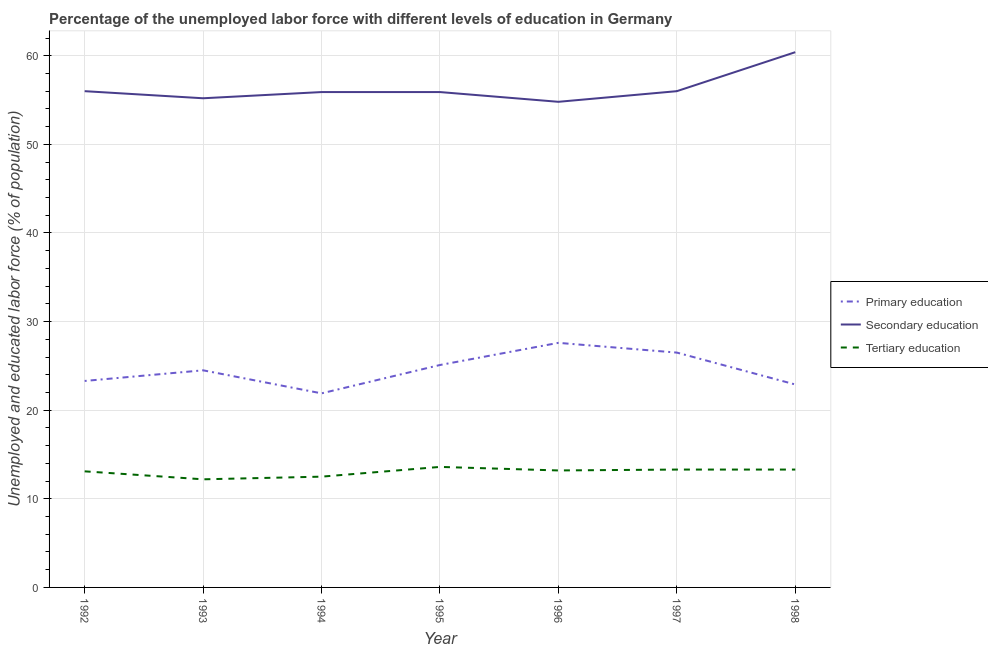How many different coloured lines are there?
Make the answer very short. 3. Does the line corresponding to percentage of labor force who received primary education intersect with the line corresponding to percentage of labor force who received tertiary education?
Provide a succinct answer. No. What is the percentage of labor force who received tertiary education in 1996?
Offer a very short reply. 13.2. Across all years, what is the maximum percentage of labor force who received primary education?
Give a very brief answer. 27.6. Across all years, what is the minimum percentage of labor force who received primary education?
Offer a terse response. 21.9. In which year was the percentage of labor force who received secondary education maximum?
Your response must be concise. 1998. What is the total percentage of labor force who received primary education in the graph?
Ensure brevity in your answer.  171.8. What is the difference between the percentage of labor force who received secondary education in 1994 and that in 1996?
Your response must be concise. 1.1. What is the difference between the percentage of labor force who received tertiary education in 1994 and the percentage of labor force who received secondary education in 1996?
Provide a short and direct response. -42.3. What is the average percentage of labor force who received secondary education per year?
Offer a very short reply. 56.31. In the year 1993, what is the difference between the percentage of labor force who received primary education and percentage of labor force who received tertiary education?
Offer a very short reply. 12.3. In how many years, is the percentage of labor force who received primary education greater than 12 %?
Make the answer very short. 7. What is the ratio of the percentage of labor force who received secondary education in 1994 to that in 1998?
Your answer should be compact. 0.93. Is the percentage of labor force who received primary education in 1994 less than that in 1996?
Your answer should be very brief. Yes. What is the difference between the highest and the second highest percentage of labor force who received primary education?
Give a very brief answer. 1.1. What is the difference between the highest and the lowest percentage of labor force who received tertiary education?
Provide a short and direct response. 1.4. In how many years, is the percentage of labor force who received secondary education greater than the average percentage of labor force who received secondary education taken over all years?
Your answer should be very brief. 1. Is the sum of the percentage of labor force who received secondary education in 1995 and 1996 greater than the maximum percentage of labor force who received tertiary education across all years?
Offer a very short reply. Yes. Is it the case that in every year, the sum of the percentage of labor force who received primary education and percentage of labor force who received secondary education is greater than the percentage of labor force who received tertiary education?
Your answer should be very brief. Yes. Does the percentage of labor force who received secondary education monotonically increase over the years?
Make the answer very short. No. Is the percentage of labor force who received tertiary education strictly less than the percentage of labor force who received primary education over the years?
Ensure brevity in your answer.  Yes. How many lines are there?
Provide a short and direct response. 3. How many years are there in the graph?
Ensure brevity in your answer.  7. What is the difference between two consecutive major ticks on the Y-axis?
Make the answer very short. 10. Are the values on the major ticks of Y-axis written in scientific E-notation?
Give a very brief answer. No. Does the graph contain any zero values?
Make the answer very short. No. Does the graph contain grids?
Ensure brevity in your answer.  Yes. Where does the legend appear in the graph?
Your answer should be compact. Center right. What is the title of the graph?
Provide a succinct answer. Percentage of the unemployed labor force with different levels of education in Germany. Does "Natural gas sources" appear as one of the legend labels in the graph?
Give a very brief answer. No. What is the label or title of the Y-axis?
Your response must be concise. Unemployed and educated labor force (% of population). What is the Unemployed and educated labor force (% of population) in Primary education in 1992?
Provide a succinct answer. 23.3. What is the Unemployed and educated labor force (% of population) of Tertiary education in 1992?
Keep it short and to the point. 13.1. What is the Unemployed and educated labor force (% of population) of Secondary education in 1993?
Offer a terse response. 55.2. What is the Unemployed and educated labor force (% of population) of Tertiary education in 1993?
Your response must be concise. 12.2. What is the Unemployed and educated labor force (% of population) of Primary education in 1994?
Offer a terse response. 21.9. What is the Unemployed and educated labor force (% of population) in Secondary education in 1994?
Provide a short and direct response. 55.9. What is the Unemployed and educated labor force (% of population) of Primary education in 1995?
Make the answer very short. 25.1. What is the Unemployed and educated labor force (% of population) in Secondary education in 1995?
Give a very brief answer. 55.9. What is the Unemployed and educated labor force (% of population) in Tertiary education in 1995?
Your answer should be compact. 13.6. What is the Unemployed and educated labor force (% of population) in Primary education in 1996?
Ensure brevity in your answer.  27.6. What is the Unemployed and educated labor force (% of population) in Secondary education in 1996?
Keep it short and to the point. 54.8. What is the Unemployed and educated labor force (% of population) of Tertiary education in 1996?
Offer a very short reply. 13.2. What is the Unemployed and educated labor force (% of population) of Secondary education in 1997?
Give a very brief answer. 56. What is the Unemployed and educated labor force (% of population) in Tertiary education in 1997?
Provide a short and direct response. 13.3. What is the Unemployed and educated labor force (% of population) in Primary education in 1998?
Offer a very short reply. 22.9. What is the Unemployed and educated labor force (% of population) in Secondary education in 1998?
Keep it short and to the point. 60.4. What is the Unemployed and educated labor force (% of population) of Tertiary education in 1998?
Provide a succinct answer. 13.3. Across all years, what is the maximum Unemployed and educated labor force (% of population) of Primary education?
Keep it short and to the point. 27.6. Across all years, what is the maximum Unemployed and educated labor force (% of population) of Secondary education?
Keep it short and to the point. 60.4. Across all years, what is the maximum Unemployed and educated labor force (% of population) of Tertiary education?
Your response must be concise. 13.6. Across all years, what is the minimum Unemployed and educated labor force (% of population) of Primary education?
Keep it short and to the point. 21.9. Across all years, what is the minimum Unemployed and educated labor force (% of population) in Secondary education?
Provide a succinct answer. 54.8. Across all years, what is the minimum Unemployed and educated labor force (% of population) in Tertiary education?
Make the answer very short. 12.2. What is the total Unemployed and educated labor force (% of population) of Primary education in the graph?
Give a very brief answer. 171.8. What is the total Unemployed and educated labor force (% of population) in Secondary education in the graph?
Offer a terse response. 394.2. What is the total Unemployed and educated labor force (% of population) in Tertiary education in the graph?
Ensure brevity in your answer.  91.2. What is the difference between the Unemployed and educated labor force (% of population) of Primary education in 1992 and that in 1993?
Keep it short and to the point. -1.2. What is the difference between the Unemployed and educated labor force (% of population) in Tertiary education in 1992 and that in 1993?
Provide a short and direct response. 0.9. What is the difference between the Unemployed and educated labor force (% of population) in Primary education in 1992 and that in 1996?
Give a very brief answer. -4.3. What is the difference between the Unemployed and educated labor force (% of population) of Tertiary education in 1992 and that in 1996?
Provide a succinct answer. -0.1. What is the difference between the Unemployed and educated labor force (% of population) in Primary education in 1992 and that in 1998?
Provide a succinct answer. 0.4. What is the difference between the Unemployed and educated labor force (% of population) of Tertiary education in 1993 and that in 1994?
Your answer should be very brief. -0.3. What is the difference between the Unemployed and educated labor force (% of population) in Secondary education in 1993 and that in 1995?
Give a very brief answer. -0.7. What is the difference between the Unemployed and educated labor force (% of population) in Primary education in 1993 and that in 1996?
Make the answer very short. -3.1. What is the difference between the Unemployed and educated labor force (% of population) of Primary education in 1993 and that in 1997?
Your answer should be very brief. -2. What is the difference between the Unemployed and educated labor force (% of population) of Secondary education in 1993 and that in 1997?
Keep it short and to the point. -0.8. What is the difference between the Unemployed and educated labor force (% of population) in Primary education in 1993 and that in 1998?
Give a very brief answer. 1.6. What is the difference between the Unemployed and educated labor force (% of population) in Secondary education in 1993 and that in 1998?
Make the answer very short. -5.2. What is the difference between the Unemployed and educated labor force (% of population) in Tertiary education in 1994 and that in 1995?
Provide a short and direct response. -1.1. What is the difference between the Unemployed and educated labor force (% of population) of Primary education in 1994 and that in 1996?
Make the answer very short. -5.7. What is the difference between the Unemployed and educated labor force (% of population) in Secondary education in 1994 and that in 1996?
Your answer should be very brief. 1.1. What is the difference between the Unemployed and educated labor force (% of population) of Primary education in 1994 and that in 1997?
Keep it short and to the point. -4.6. What is the difference between the Unemployed and educated labor force (% of population) of Secondary education in 1994 and that in 1997?
Provide a short and direct response. -0.1. What is the difference between the Unemployed and educated labor force (% of population) of Primary education in 1994 and that in 1998?
Offer a very short reply. -1. What is the difference between the Unemployed and educated labor force (% of population) of Primary education in 1995 and that in 1996?
Offer a very short reply. -2.5. What is the difference between the Unemployed and educated labor force (% of population) in Primary education in 1995 and that in 1997?
Offer a very short reply. -1.4. What is the difference between the Unemployed and educated labor force (% of population) of Secondary education in 1995 and that in 1997?
Your response must be concise. -0.1. What is the difference between the Unemployed and educated labor force (% of population) of Primary education in 1995 and that in 1998?
Keep it short and to the point. 2.2. What is the difference between the Unemployed and educated labor force (% of population) of Secondary education in 1995 and that in 1998?
Provide a succinct answer. -4.5. What is the difference between the Unemployed and educated labor force (% of population) of Tertiary education in 1995 and that in 1998?
Keep it short and to the point. 0.3. What is the difference between the Unemployed and educated labor force (% of population) of Primary education in 1996 and that in 1997?
Your answer should be very brief. 1.1. What is the difference between the Unemployed and educated labor force (% of population) in Secondary education in 1996 and that in 1997?
Offer a terse response. -1.2. What is the difference between the Unemployed and educated labor force (% of population) of Tertiary education in 1996 and that in 1997?
Your answer should be very brief. -0.1. What is the difference between the Unemployed and educated labor force (% of population) of Primary education in 1996 and that in 1998?
Provide a short and direct response. 4.7. What is the difference between the Unemployed and educated labor force (% of population) of Primary education in 1997 and that in 1998?
Provide a succinct answer. 3.6. What is the difference between the Unemployed and educated labor force (% of population) of Tertiary education in 1997 and that in 1998?
Your answer should be compact. 0. What is the difference between the Unemployed and educated labor force (% of population) of Primary education in 1992 and the Unemployed and educated labor force (% of population) of Secondary education in 1993?
Your answer should be very brief. -31.9. What is the difference between the Unemployed and educated labor force (% of population) of Secondary education in 1992 and the Unemployed and educated labor force (% of population) of Tertiary education in 1993?
Ensure brevity in your answer.  43.8. What is the difference between the Unemployed and educated labor force (% of population) of Primary education in 1992 and the Unemployed and educated labor force (% of population) of Secondary education in 1994?
Provide a succinct answer. -32.6. What is the difference between the Unemployed and educated labor force (% of population) of Primary education in 1992 and the Unemployed and educated labor force (% of population) of Tertiary education in 1994?
Your response must be concise. 10.8. What is the difference between the Unemployed and educated labor force (% of population) of Secondary education in 1992 and the Unemployed and educated labor force (% of population) of Tertiary education in 1994?
Ensure brevity in your answer.  43.5. What is the difference between the Unemployed and educated labor force (% of population) of Primary education in 1992 and the Unemployed and educated labor force (% of population) of Secondary education in 1995?
Keep it short and to the point. -32.6. What is the difference between the Unemployed and educated labor force (% of population) of Primary education in 1992 and the Unemployed and educated labor force (% of population) of Tertiary education in 1995?
Offer a terse response. 9.7. What is the difference between the Unemployed and educated labor force (% of population) in Secondary education in 1992 and the Unemployed and educated labor force (% of population) in Tertiary education in 1995?
Your answer should be compact. 42.4. What is the difference between the Unemployed and educated labor force (% of population) in Primary education in 1992 and the Unemployed and educated labor force (% of population) in Secondary education in 1996?
Your answer should be compact. -31.5. What is the difference between the Unemployed and educated labor force (% of population) in Primary education in 1992 and the Unemployed and educated labor force (% of population) in Tertiary education in 1996?
Your response must be concise. 10.1. What is the difference between the Unemployed and educated labor force (% of population) of Secondary education in 1992 and the Unemployed and educated labor force (% of population) of Tertiary education in 1996?
Ensure brevity in your answer.  42.8. What is the difference between the Unemployed and educated labor force (% of population) of Primary education in 1992 and the Unemployed and educated labor force (% of population) of Secondary education in 1997?
Your response must be concise. -32.7. What is the difference between the Unemployed and educated labor force (% of population) in Secondary education in 1992 and the Unemployed and educated labor force (% of population) in Tertiary education in 1997?
Your answer should be compact. 42.7. What is the difference between the Unemployed and educated labor force (% of population) of Primary education in 1992 and the Unemployed and educated labor force (% of population) of Secondary education in 1998?
Give a very brief answer. -37.1. What is the difference between the Unemployed and educated labor force (% of population) in Primary education in 1992 and the Unemployed and educated labor force (% of population) in Tertiary education in 1998?
Give a very brief answer. 10. What is the difference between the Unemployed and educated labor force (% of population) of Secondary education in 1992 and the Unemployed and educated labor force (% of population) of Tertiary education in 1998?
Your answer should be very brief. 42.7. What is the difference between the Unemployed and educated labor force (% of population) of Primary education in 1993 and the Unemployed and educated labor force (% of population) of Secondary education in 1994?
Give a very brief answer. -31.4. What is the difference between the Unemployed and educated labor force (% of population) of Primary education in 1993 and the Unemployed and educated labor force (% of population) of Tertiary education in 1994?
Provide a succinct answer. 12. What is the difference between the Unemployed and educated labor force (% of population) in Secondary education in 1993 and the Unemployed and educated labor force (% of population) in Tertiary education in 1994?
Your answer should be compact. 42.7. What is the difference between the Unemployed and educated labor force (% of population) of Primary education in 1993 and the Unemployed and educated labor force (% of population) of Secondary education in 1995?
Ensure brevity in your answer.  -31.4. What is the difference between the Unemployed and educated labor force (% of population) of Secondary education in 1993 and the Unemployed and educated labor force (% of population) of Tertiary education in 1995?
Offer a very short reply. 41.6. What is the difference between the Unemployed and educated labor force (% of population) of Primary education in 1993 and the Unemployed and educated labor force (% of population) of Secondary education in 1996?
Your answer should be very brief. -30.3. What is the difference between the Unemployed and educated labor force (% of population) in Secondary education in 1993 and the Unemployed and educated labor force (% of population) in Tertiary education in 1996?
Keep it short and to the point. 42. What is the difference between the Unemployed and educated labor force (% of population) of Primary education in 1993 and the Unemployed and educated labor force (% of population) of Secondary education in 1997?
Give a very brief answer. -31.5. What is the difference between the Unemployed and educated labor force (% of population) in Secondary education in 1993 and the Unemployed and educated labor force (% of population) in Tertiary education in 1997?
Give a very brief answer. 41.9. What is the difference between the Unemployed and educated labor force (% of population) in Primary education in 1993 and the Unemployed and educated labor force (% of population) in Secondary education in 1998?
Your answer should be very brief. -35.9. What is the difference between the Unemployed and educated labor force (% of population) of Secondary education in 1993 and the Unemployed and educated labor force (% of population) of Tertiary education in 1998?
Provide a succinct answer. 41.9. What is the difference between the Unemployed and educated labor force (% of population) in Primary education in 1994 and the Unemployed and educated labor force (% of population) in Secondary education in 1995?
Your answer should be very brief. -34. What is the difference between the Unemployed and educated labor force (% of population) in Secondary education in 1994 and the Unemployed and educated labor force (% of population) in Tertiary education in 1995?
Offer a terse response. 42.3. What is the difference between the Unemployed and educated labor force (% of population) of Primary education in 1994 and the Unemployed and educated labor force (% of population) of Secondary education in 1996?
Provide a succinct answer. -32.9. What is the difference between the Unemployed and educated labor force (% of population) of Secondary education in 1994 and the Unemployed and educated labor force (% of population) of Tertiary education in 1996?
Offer a very short reply. 42.7. What is the difference between the Unemployed and educated labor force (% of population) of Primary education in 1994 and the Unemployed and educated labor force (% of population) of Secondary education in 1997?
Provide a short and direct response. -34.1. What is the difference between the Unemployed and educated labor force (% of population) in Primary education in 1994 and the Unemployed and educated labor force (% of population) in Tertiary education in 1997?
Your answer should be very brief. 8.6. What is the difference between the Unemployed and educated labor force (% of population) in Secondary education in 1994 and the Unemployed and educated labor force (% of population) in Tertiary education in 1997?
Keep it short and to the point. 42.6. What is the difference between the Unemployed and educated labor force (% of population) of Primary education in 1994 and the Unemployed and educated labor force (% of population) of Secondary education in 1998?
Offer a very short reply. -38.5. What is the difference between the Unemployed and educated labor force (% of population) of Secondary education in 1994 and the Unemployed and educated labor force (% of population) of Tertiary education in 1998?
Your response must be concise. 42.6. What is the difference between the Unemployed and educated labor force (% of population) of Primary education in 1995 and the Unemployed and educated labor force (% of population) of Secondary education in 1996?
Provide a short and direct response. -29.7. What is the difference between the Unemployed and educated labor force (% of population) in Secondary education in 1995 and the Unemployed and educated labor force (% of population) in Tertiary education in 1996?
Offer a terse response. 42.7. What is the difference between the Unemployed and educated labor force (% of population) in Primary education in 1995 and the Unemployed and educated labor force (% of population) in Secondary education in 1997?
Give a very brief answer. -30.9. What is the difference between the Unemployed and educated labor force (% of population) in Secondary education in 1995 and the Unemployed and educated labor force (% of population) in Tertiary education in 1997?
Your answer should be very brief. 42.6. What is the difference between the Unemployed and educated labor force (% of population) in Primary education in 1995 and the Unemployed and educated labor force (% of population) in Secondary education in 1998?
Your answer should be very brief. -35.3. What is the difference between the Unemployed and educated labor force (% of population) of Secondary education in 1995 and the Unemployed and educated labor force (% of population) of Tertiary education in 1998?
Ensure brevity in your answer.  42.6. What is the difference between the Unemployed and educated labor force (% of population) in Primary education in 1996 and the Unemployed and educated labor force (% of population) in Secondary education in 1997?
Make the answer very short. -28.4. What is the difference between the Unemployed and educated labor force (% of population) of Primary education in 1996 and the Unemployed and educated labor force (% of population) of Tertiary education in 1997?
Keep it short and to the point. 14.3. What is the difference between the Unemployed and educated labor force (% of population) in Secondary education in 1996 and the Unemployed and educated labor force (% of population) in Tertiary education in 1997?
Ensure brevity in your answer.  41.5. What is the difference between the Unemployed and educated labor force (% of population) of Primary education in 1996 and the Unemployed and educated labor force (% of population) of Secondary education in 1998?
Offer a very short reply. -32.8. What is the difference between the Unemployed and educated labor force (% of population) of Secondary education in 1996 and the Unemployed and educated labor force (% of population) of Tertiary education in 1998?
Give a very brief answer. 41.5. What is the difference between the Unemployed and educated labor force (% of population) of Primary education in 1997 and the Unemployed and educated labor force (% of population) of Secondary education in 1998?
Provide a succinct answer. -33.9. What is the difference between the Unemployed and educated labor force (% of population) in Secondary education in 1997 and the Unemployed and educated labor force (% of population) in Tertiary education in 1998?
Provide a succinct answer. 42.7. What is the average Unemployed and educated labor force (% of population) of Primary education per year?
Ensure brevity in your answer.  24.54. What is the average Unemployed and educated labor force (% of population) in Secondary education per year?
Give a very brief answer. 56.31. What is the average Unemployed and educated labor force (% of population) in Tertiary education per year?
Provide a succinct answer. 13.03. In the year 1992, what is the difference between the Unemployed and educated labor force (% of population) in Primary education and Unemployed and educated labor force (% of population) in Secondary education?
Your response must be concise. -32.7. In the year 1992, what is the difference between the Unemployed and educated labor force (% of population) in Secondary education and Unemployed and educated labor force (% of population) in Tertiary education?
Make the answer very short. 42.9. In the year 1993, what is the difference between the Unemployed and educated labor force (% of population) of Primary education and Unemployed and educated labor force (% of population) of Secondary education?
Your answer should be very brief. -30.7. In the year 1993, what is the difference between the Unemployed and educated labor force (% of population) of Secondary education and Unemployed and educated labor force (% of population) of Tertiary education?
Give a very brief answer. 43. In the year 1994, what is the difference between the Unemployed and educated labor force (% of population) in Primary education and Unemployed and educated labor force (% of population) in Secondary education?
Provide a short and direct response. -34. In the year 1994, what is the difference between the Unemployed and educated labor force (% of population) in Secondary education and Unemployed and educated labor force (% of population) in Tertiary education?
Your answer should be compact. 43.4. In the year 1995, what is the difference between the Unemployed and educated labor force (% of population) of Primary education and Unemployed and educated labor force (% of population) of Secondary education?
Keep it short and to the point. -30.8. In the year 1995, what is the difference between the Unemployed and educated labor force (% of population) of Secondary education and Unemployed and educated labor force (% of population) of Tertiary education?
Your answer should be very brief. 42.3. In the year 1996, what is the difference between the Unemployed and educated labor force (% of population) in Primary education and Unemployed and educated labor force (% of population) in Secondary education?
Give a very brief answer. -27.2. In the year 1996, what is the difference between the Unemployed and educated labor force (% of population) in Primary education and Unemployed and educated labor force (% of population) in Tertiary education?
Your answer should be compact. 14.4. In the year 1996, what is the difference between the Unemployed and educated labor force (% of population) in Secondary education and Unemployed and educated labor force (% of population) in Tertiary education?
Ensure brevity in your answer.  41.6. In the year 1997, what is the difference between the Unemployed and educated labor force (% of population) in Primary education and Unemployed and educated labor force (% of population) in Secondary education?
Your response must be concise. -29.5. In the year 1997, what is the difference between the Unemployed and educated labor force (% of population) in Secondary education and Unemployed and educated labor force (% of population) in Tertiary education?
Ensure brevity in your answer.  42.7. In the year 1998, what is the difference between the Unemployed and educated labor force (% of population) of Primary education and Unemployed and educated labor force (% of population) of Secondary education?
Your response must be concise. -37.5. In the year 1998, what is the difference between the Unemployed and educated labor force (% of population) in Secondary education and Unemployed and educated labor force (% of population) in Tertiary education?
Offer a terse response. 47.1. What is the ratio of the Unemployed and educated labor force (% of population) in Primary education in 1992 to that in 1993?
Keep it short and to the point. 0.95. What is the ratio of the Unemployed and educated labor force (% of population) of Secondary education in 1992 to that in 1993?
Offer a terse response. 1.01. What is the ratio of the Unemployed and educated labor force (% of population) in Tertiary education in 1992 to that in 1993?
Your answer should be very brief. 1.07. What is the ratio of the Unemployed and educated labor force (% of population) of Primary education in 1992 to that in 1994?
Provide a succinct answer. 1.06. What is the ratio of the Unemployed and educated labor force (% of population) of Tertiary education in 1992 to that in 1994?
Your answer should be very brief. 1.05. What is the ratio of the Unemployed and educated labor force (% of population) of Primary education in 1992 to that in 1995?
Offer a terse response. 0.93. What is the ratio of the Unemployed and educated labor force (% of population) in Secondary education in 1992 to that in 1995?
Your answer should be very brief. 1. What is the ratio of the Unemployed and educated labor force (% of population) in Tertiary education in 1992 to that in 1995?
Your response must be concise. 0.96. What is the ratio of the Unemployed and educated labor force (% of population) of Primary education in 1992 to that in 1996?
Provide a short and direct response. 0.84. What is the ratio of the Unemployed and educated labor force (% of population) in Secondary education in 1992 to that in 1996?
Give a very brief answer. 1.02. What is the ratio of the Unemployed and educated labor force (% of population) in Tertiary education in 1992 to that in 1996?
Your answer should be very brief. 0.99. What is the ratio of the Unemployed and educated labor force (% of population) in Primary education in 1992 to that in 1997?
Your response must be concise. 0.88. What is the ratio of the Unemployed and educated labor force (% of population) of Tertiary education in 1992 to that in 1997?
Ensure brevity in your answer.  0.98. What is the ratio of the Unemployed and educated labor force (% of population) of Primary education in 1992 to that in 1998?
Provide a short and direct response. 1.02. What is the ratio of the Unemployed and educated labor force (% of population) of Secondary education in 1992 to that in 1998?
Provide a short and direct response. 0.93. What is the ratio of the Unemployed and educated labor force (% of population) in Primary education in 1993 to that in 1994?
Your answer should be compact. 1.12. What is the ratio of the Unemployed and educated labor force (% of population) in Secondary education in 1993 to that in 1994?
Offer a very short reply. 0.99. What is the ratio of the Unemployed and educated labor force (% of population) in Primary education in 1993 to that in 1995?
Offer a very short reply. 0.98. What is the ratio of the Unemployed and educated labor force (% of population) of Secondary education in 1993 to that in 1995?
Your response must be concise. 0.99. What is the ratio of the Unemployed and educated labor force (% of population) in Tertiary education in 1993 to that in 1995?
Your answer should be compact. 0.9. What is the ratio of the Unemployed and educated labor force (% of population) in Primary education in 1993 to that in 1996?
Your response must be concise. 0.89. What is the ratio of the Unemployed and educated labor force (% of population) in Secondary education in 1993 to that in 1996?
Keep it short and to the point. 1.01. What is the ratio of the Unemployed and educated labor force (% of population) in Tertiary education in 1993 to that in 1996?
Ensure brevity in your answer.  0.92. What is the ratio of the Unemployed and educated labor force (% of population) in Primary education in 1993 to that in 1997?
Offer a very short reply. 0.92. What is the ratio of the Unemployed and educated labor force (% of population) in Secondary education in 1993 to that in 1997?
Your response must be concise. 0.99. What is the ratio of the Unemployed and educated labor force (% of population) of Tertiary education in 1993 to that in 1997?
Make the answer very short. 0.92. What is the ratio of the Unemployed and educated labor force (% of population) in Primary education in 1993 to that in 1998?
Your answer should be very brief. 1.07. What is the ratio of the Unemployed and educated labor force (% of population) of Secondary education in 1993 to that in 1998?
Offer a terse response. 0.91. What is the ratio of the Unemployed and educated labor force (% of population) in Tertiary education in 1993 to that in 1998?
Offer a terse response. 0.92. What is the ratio of the Unemployed and educated labor force (% of population) in Primary education in 1994 to that in 1995?
Your answer should be compact. 0.87. What is the ratio of the Unemployed and educated labor force (% of population) of Secondary education in 1994 to that in 1995?
Your answer should be compact. 1. What is the ratio of the Unemployed and educated labor force (% of population) of Tertiary education in 1994 to that in 1995?
Provide a short and direct response. 0.92. What is the ratio of the Unemployed and educated labor force (% of population) in Primary education in 1994 to that in 1996?
Your answer should be compact. 0.79. What is the ratio of the Unemployed and educated labor force (% of population) of Secondary education in 1994 to that in 1996?
Make the answer very short. 1.02. What is the ratio of the Unemployed and educated labor force (% of population) of Tertiary education in 1994 to that in 1996?
Ensure brevity in your answer.  0.95. What is the ratio of the Unemployed and educated labor force (% of population) of Primary education in 1994 to that in 1997?
Your answer should be compact. 0.83. What is the ratio of the Unemployed and educated labor force (% of population) in Secondary education in 1994 to that in 1997?
Your answer should be very brief. 1. What is the ratio of the Unemployed and educated labor force (% of population) of Tertiary education in 1994 to that in 1997?
Offer a very short reply. 0.94. What is the ratio of the Unemployed and educated labor force (% of population) of Primary education in 1994 to that in 1998?
Your answer should be very brief. 0.96. What is the ratio of the Unemployed and educated labor force (% of population) of Secondary education in 1994 to that in 1998?
Provide a succinct answer. 0.93. What is the ratio of the Unemployed and educated labor force (% of population) in Tertiary education in 1994 to that in 1998?
Ensure brevity in your answer.  0.94. What is the ratio of the Unemployed and educated labor force (% of population) in Primary education in 1995 to that in 1996?
Your answer should be compact. 0.91. What is the ratio of the Unemployed and educated labor force (% of population) of Secondary education in 1995 to that in 1996?
Your answer should be compact. 1.02. What is the ratio of the Unemployed and educated labor force (% of population) in Tertiary education in 1995 to that in 1996?
Ensure brevity in your answer.  1.03. What is the ratio of the Unemployed and educated labor force (% of population) of Primary education in 1995 to that in 1997?
Provide a short and direct response. 0.95. What is the ratio of the Unemployed and educated labor force (% of population) in Secondary education in 1995 to that in 1997?
Your response must be concise. 1. What is the ratio of the Unemployed and educated labor force (% of population) in Tertiary education in 1995 to that in 1997?
Provide a short and direct response. 1.02. What is the ratio of the Unemployed and educated labor force (% of population) in Primary education in 1995 to that in 1998?
Offer a terse response. 1.1. What is the ratio of the Unemployed and educated labor force (% of population) of Secondary education in 1995 to that in 1998?
Provide a short and direct response. 0.93. What is the ratio of the Unemployed and educated labor force (% of population) in Tertiary education in 1995 to that in 1998?
Your answer should be very brief. 1.02. What is the ratio of the Unemployed and educated labor force (% of population) in Primary education in 1996 to that in 1997?
Ensure brevity in your answer.  1.04. What is the ratio of the Unemployed and educated labor force (% of population) in Secondary education in 1996 to that in 1997?
Give a very brief answer. 0.98. What is the ratio of the Unemployed and educated labor force (% of population) in Primary education in 1996 to that in 1998?
Give a very brief answer. 1.21. What is the ratio of the Unemployed and educated labor force (% of population) of Secondary education in 1996 to that in 1998?
Make the answer very short. 0.91. What is the ratio of the Unemployed and educated labor force (% of population) of Primary education in 1997 to that in 1998?
Ensure brevity in your answer.  1.16. What is the ratio of the Unemployed and educated labor force (% of population) of Secondary education in 1997 to that in 1998?
Your response must be concise. 0.93. What is the difference between the highest and the second highest Unemployed and educated labor force (% of population) of Secondary education?
Give a very brief answer. 4.4. What is the difference between the highest and the second highest Unemployed and educated labor force (% of population) in Tertiary education?
Make the answer very short. 0.3. What is the difference between the highest and the lowest Unemployed and educated labor force (% of population) of Tertiary education?
Make the answer very short. 1.4. 